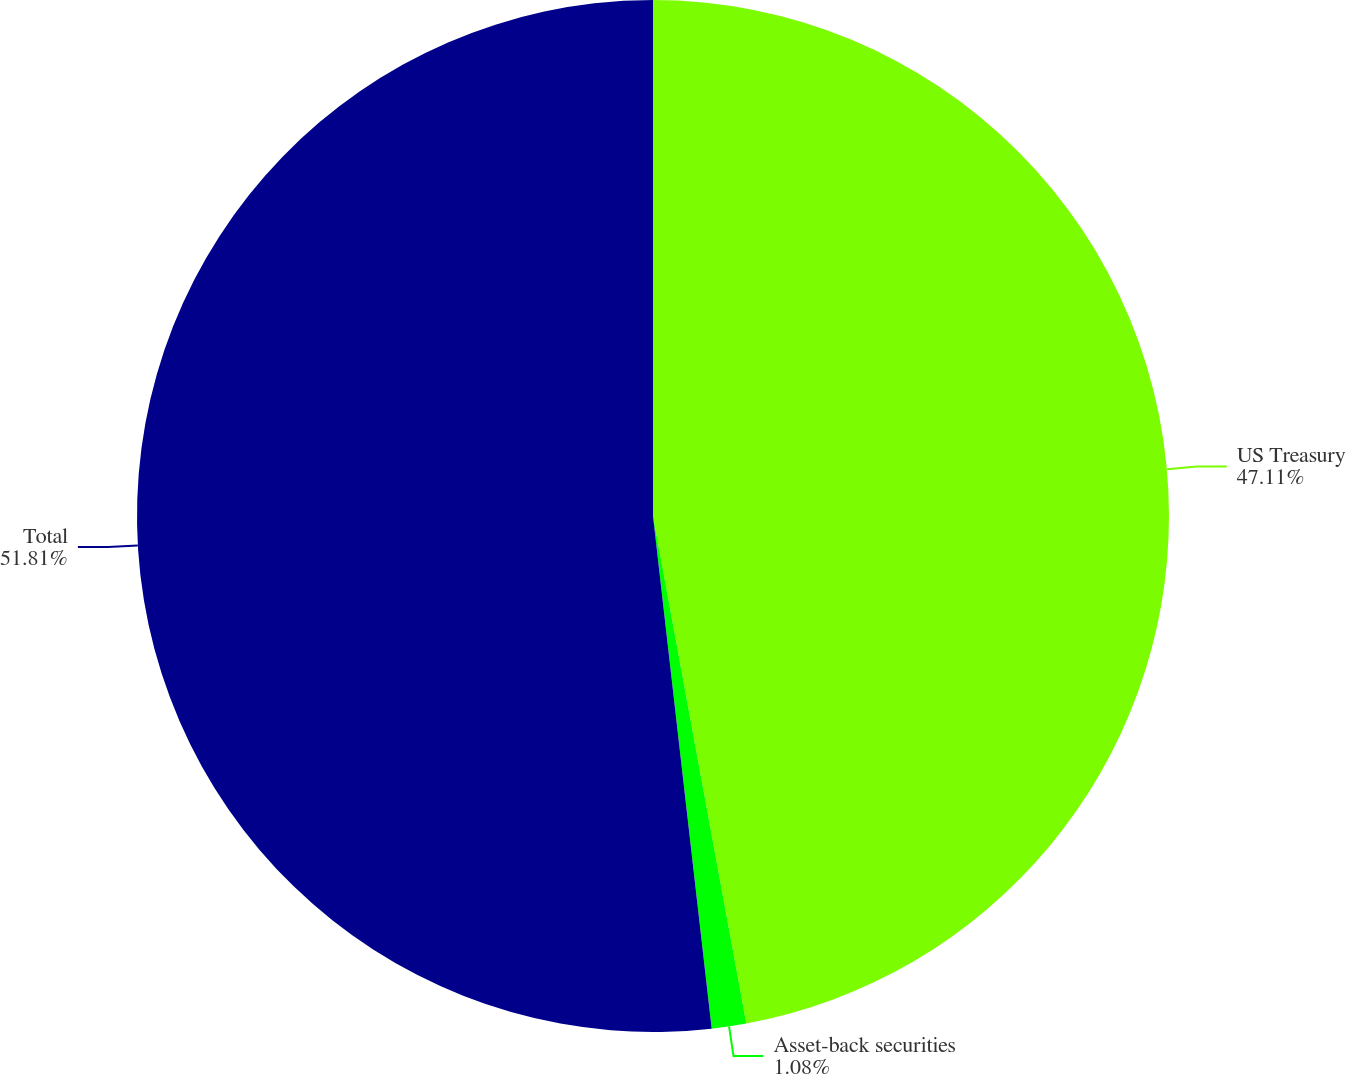<chart> <loc_0><loc_0><loc_500><loc_500><pie_chart><fcel>US Treasury<fcel>Asset-back securities<fcel>Total<nl><fcel>47.11%<fcel>1.08%<fcel>51.82%<nl></chart> 